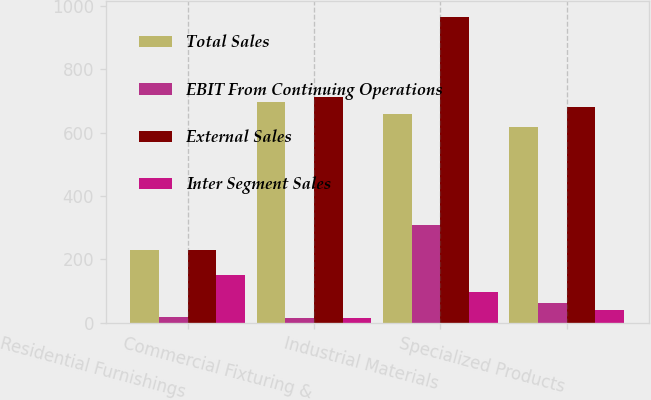Convert chart to OTSL. <chart><loc_0><loc_0><loc_500><loc_500><stacked_bar_chart><ecel><fcel>Residential Furnishings<fcel>Commercial Fixturing &<fcel>Industrial Materials<fcel>Specialized Products<nl><fcel>Total Sales<fcel>229.35<fcel>696.9<fcel>658.2<fcel>618.7<nl><fcel>EBIT From Continuing Operations<fcel>17.5<fcel>14.4<fcel>308<fcel>63<nl><fcel>External Sales<fcel>229.35<fcel>711.3<fcel>966.2<fcel>681.7<nl><fcel>Inter Segment Sales<fcel>150.7<fcel>13.8<fcel>95.5<fcel>40.7<nl></chart> 